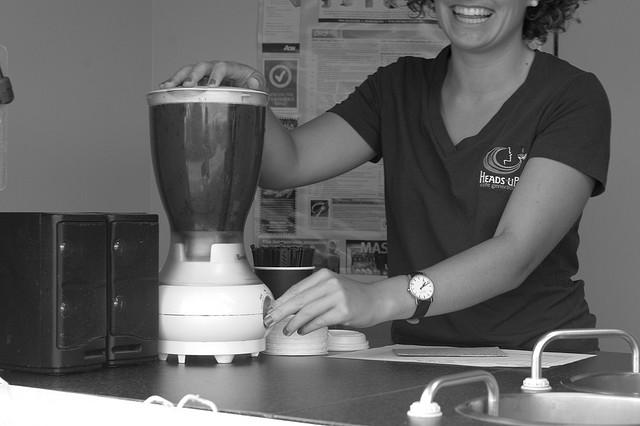What appliance is this woman using?
Concise answer only. Blender. What is on the person's left wrist?
Short answer required. Watch. Is this person happy?
Write a very short answer. Yes. 